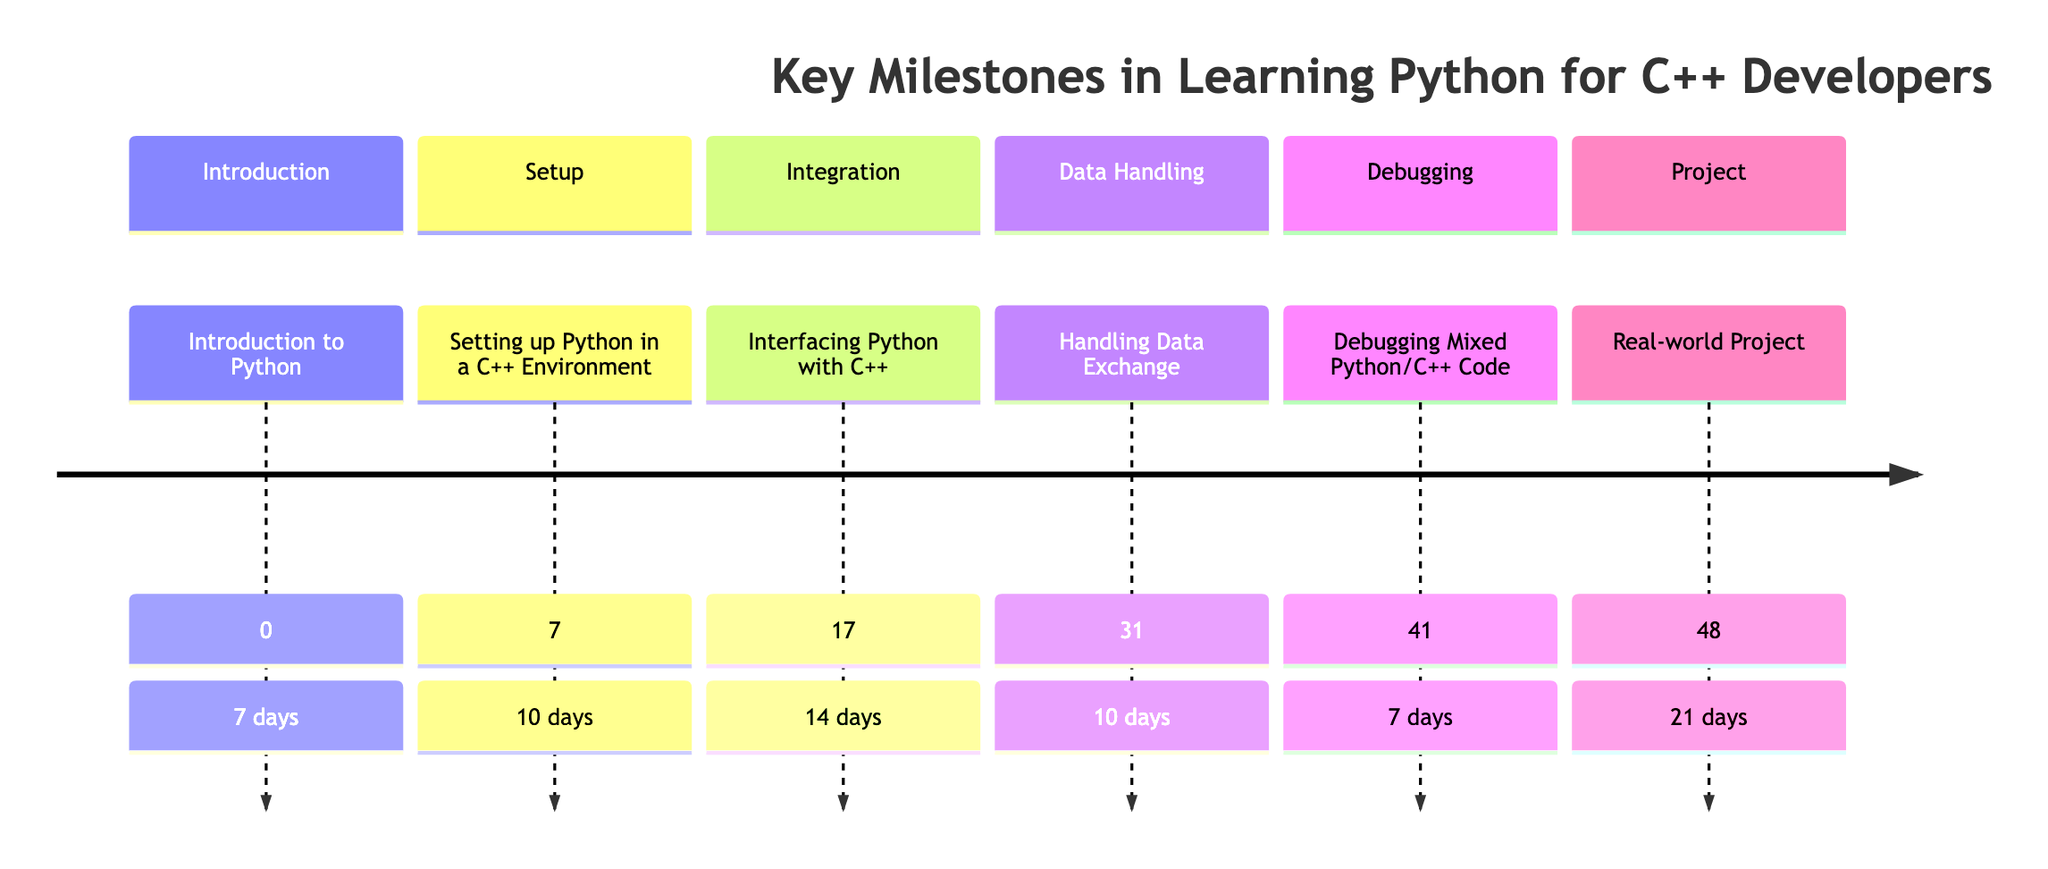What is the total time estimate for all milestones? To find the total time estimate, sum the days for each milestone: 7 + 10 + 14 + 10 + 7 + 21 = 69 days.
Answer: 69 days What is the first milestone in learning Python for C++ developers? Referring to the diagram, the first milestone is titled "Introduction to Python."
Answer: Introduction to Python Which milestone takes the longest time to complete? The milestone "Real-world Project" has a time estimate of 21 days, which is the longest compared to others.
Answer: Real-world Project How many total milestones are shown in the diagram? Count the milestones listed: Introduction to Python, Setting up Python in a C++ Environment, Interfacing Python with C++, Handling Data Exchange, Debugging Mixed Python/C++ Code, Real-world Project. This is a total of 6 milestones.
Answer: 6 What is the time estimate for debugging mixed Python/C++ code? The diagram indicates that the time estimate for "Debugging Mixed Python/C++ Code" is 7 days.
Answer: 7 days Which step comes immediately after "Handling Data Exchange"? Looking at the timeline, "Debugging Mixed Python/C++ Code" follows immediately after "Handling Data Exchange."
Answer: Debugging Mixed Python/C++ Code What is the relationship between the "Introduction to Python" and "Setting up Python in a C++ Environment"? "Setting up Python in a C++ Environment" comes directly after "Introduction to Python", indicating that it is the next milestone in the timeline.
Answer: Next Which milestone has a focus on real-world application? The milestone titled "Real-world Project" focuses on real-world applications of the skills learned.
Answer: Real-world Project What is the time estimate for interfacing Python with C++? The milestone "Interfacing Python with C++" is estimated to take 14 days according to the diagram.
Answer: 14 days 